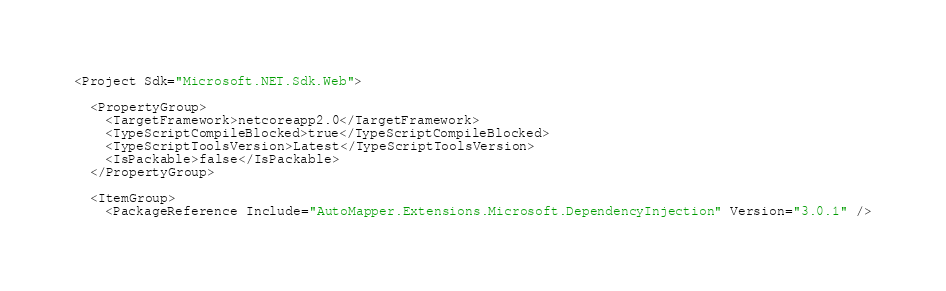<code> <loc_0><loc_0><loc_500><loc_500><_XML_><Project Sdk="Microsoft.NET.Sdk.Web">

  <PropertyGroup>
    <TargetFramework>netcoreapp2.0</TargetFramework>
    <TypeScriptCompileBlocked>true</TypeScriptCompileBlocked>
    <TypeScriptToolsVersion>Latest</TypeScriptToolsVersion>
    <IsPackable>false</IsPackable>
  </PropertyGroup>

  <ItemGroup>
    <PackageReference Include="AutoMapper.Extensions.Microsoft.DependencyInjection" Version="3.0.1" /></code> 